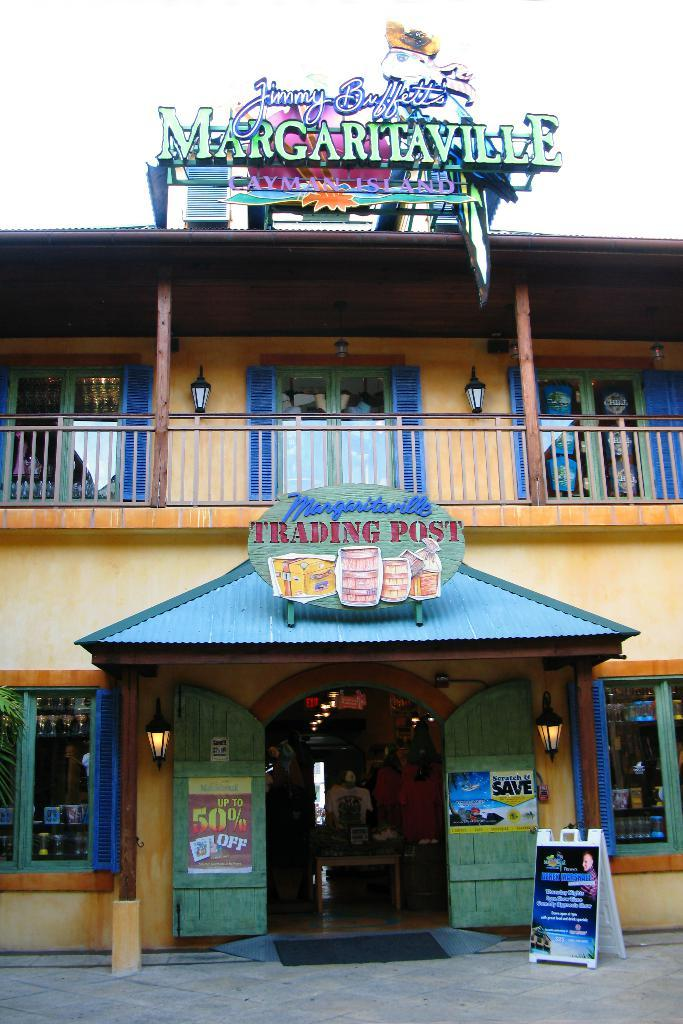<image>
Provide a brief description of the given image. a building with a sign on it that says 'margaritaville trading post' 